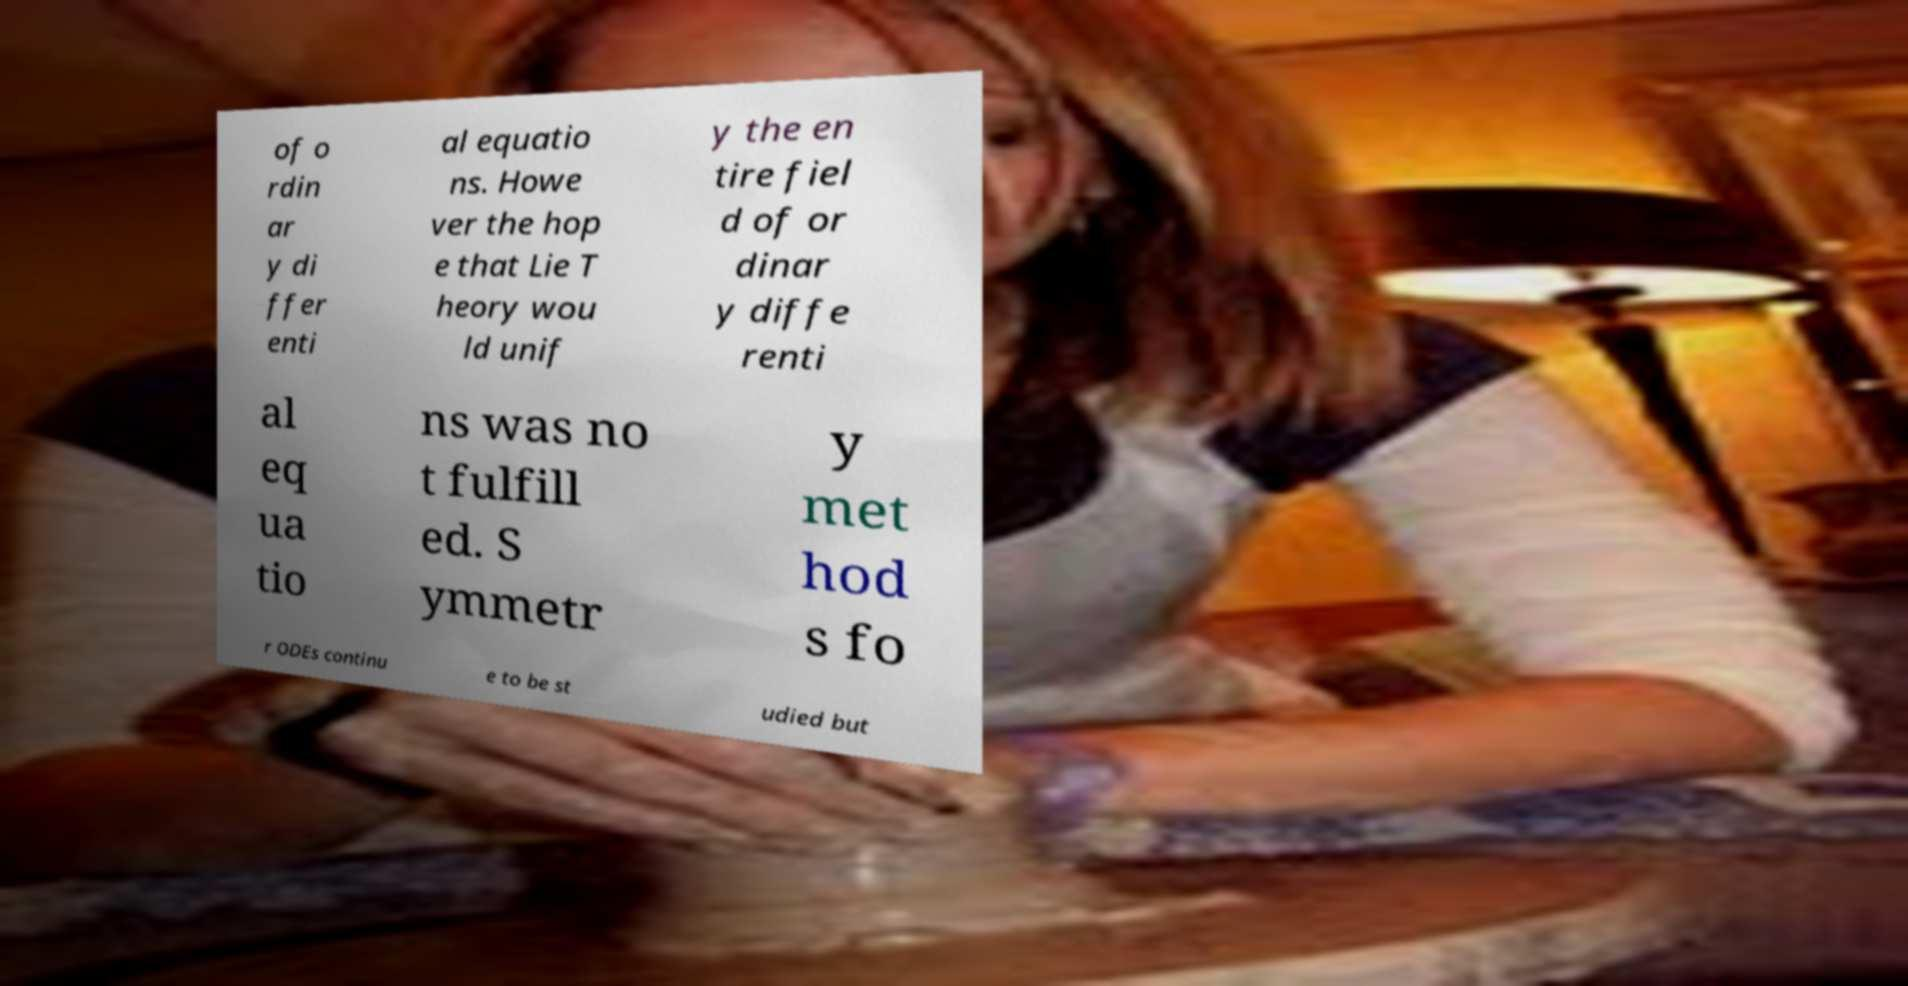What messages or text are displayed in this image? I need them in a readable, typed format. of o rdin ar y di ffer enti al equatio ns. Howe ver the hop e that Lie T heory wou ld unif y the en tire fiel d of or dinar y diffe renti al eq ua tio ns was no t fulfill ed. S ymmetr y met hod s fo r ODEs continu e to be st udied but 